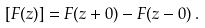Convert formula to latex. <formula><loc_0><loc_0><loc_500><loc_500>\left [ F ( z ) \right ] = F ( z + 0 ) - F ( z - 0 ) \, { . }</formula> 